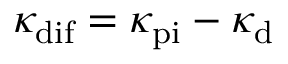<formula> <loc_0><loc_0><loc_500><loc_500>\kappa _ { d i f } = \kappa _ { p i } - \kappa _ { d }</formula> 